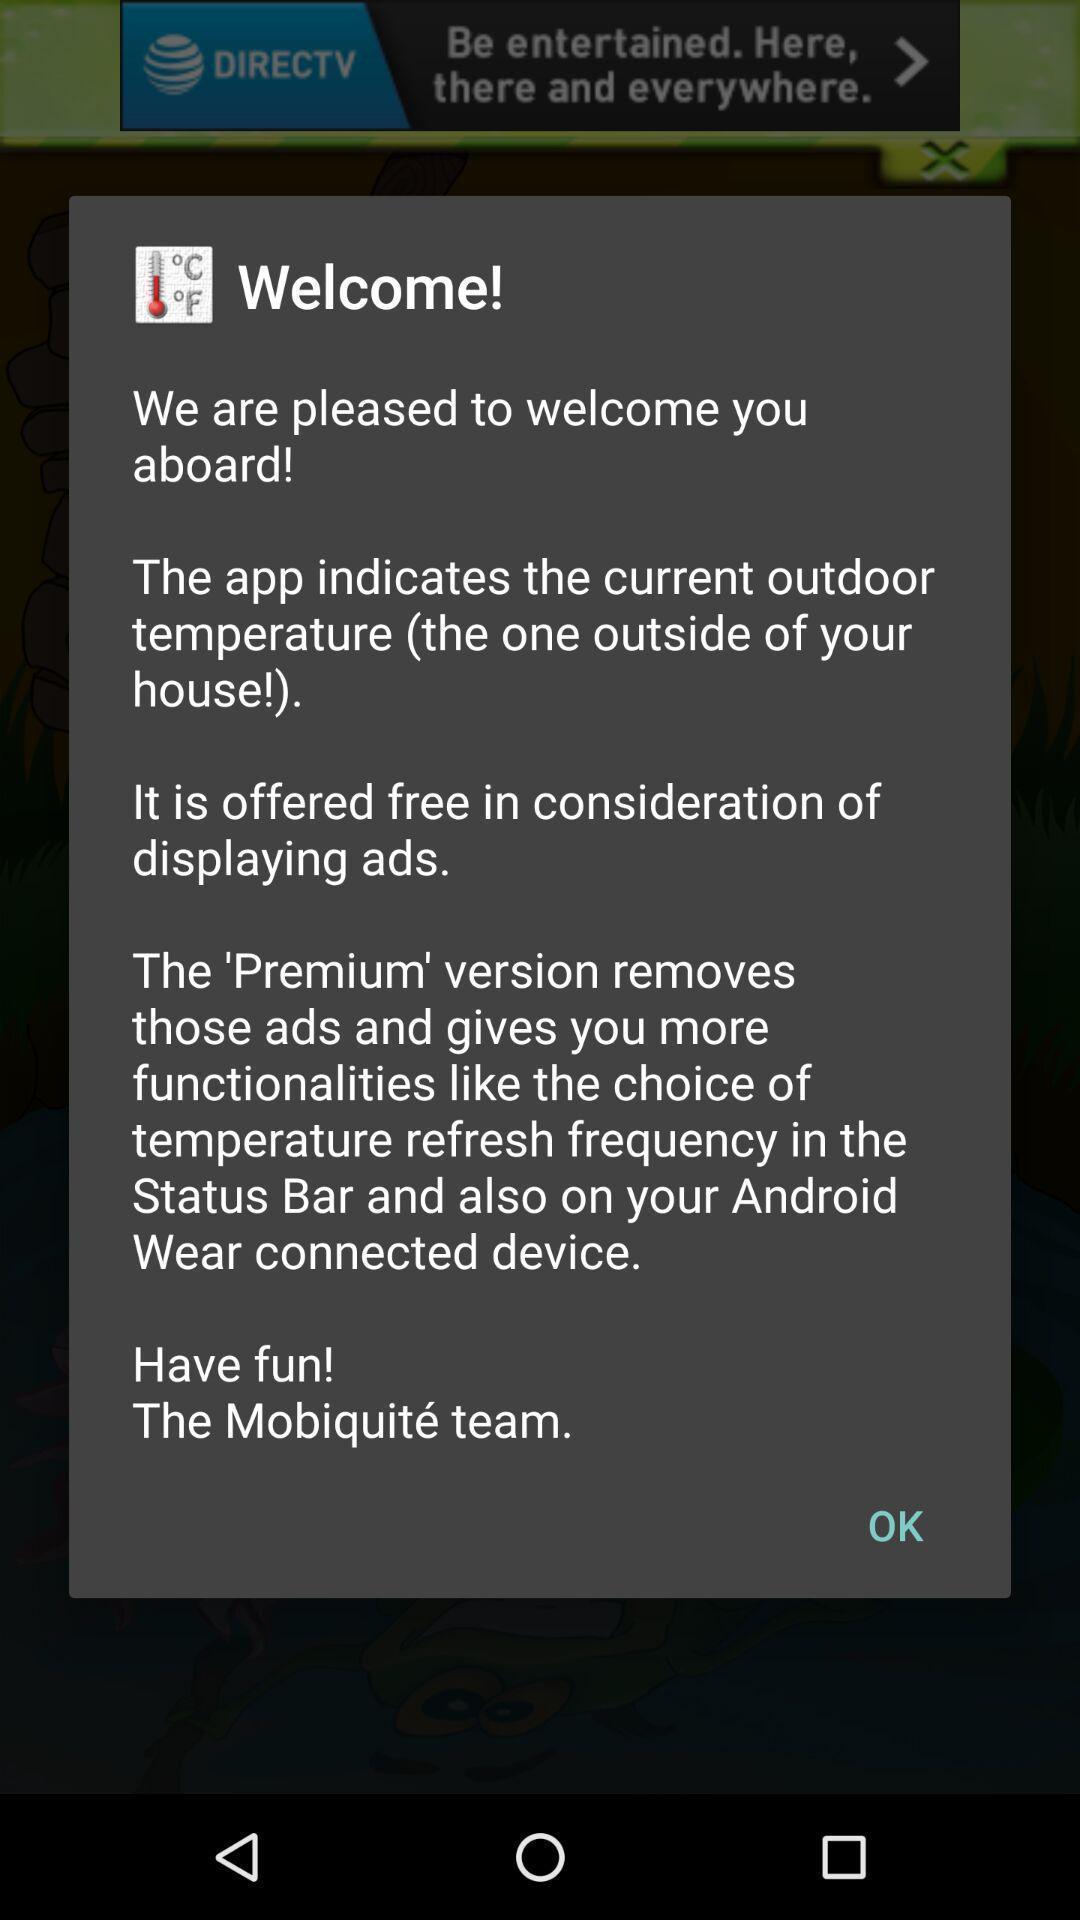What is the overall content of this screenshot? Welcome page of social app. 